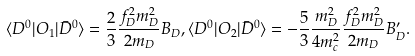Convert formula to latex. <formula><loc_0><loc_0><loc_500><loc_500>\langle D ^ { 0 } | O _ { 1 } | \bar { D } ^ { 0 } \rangle = \frac { 2 } { 3 } \frac { f _ { D } ^ { 2 } m _ { D } ^ { 2 } } { 2 m _ { D } } B _ { D } , \langle D ^ { 0 } | O _ { 2 } | \bar { D } ^ { 0 } \rangle = - \frac { 5 } { 3 } \frac { m _ { D } ^ { 2 } } { 4 m _ { c } ^ { 2 } } \frac { f _ { D } ^ { 2 } m _ { D } ^ { 2 } } { 2 m _ { D } } B _ { D } ^ { \prime } .</formula> 